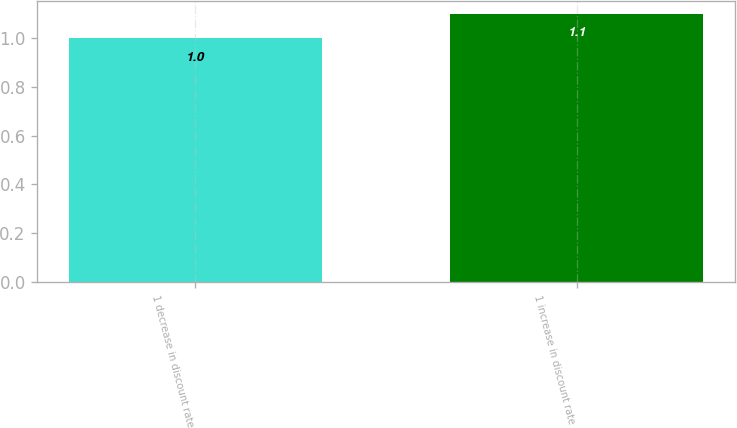Convert chart to OTSL. <chart><loc_0><loc_0><loc_500><loc_500><bar_chart><fcel>1 decrease in discount rate<fcel>1 increase in discount rate<nl><fcel>1<fcel>1.1<nl></chart> 